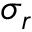<formula> <loc_0><loc_0><loc_500><loc_500>\sigma _ { r }</formula> 